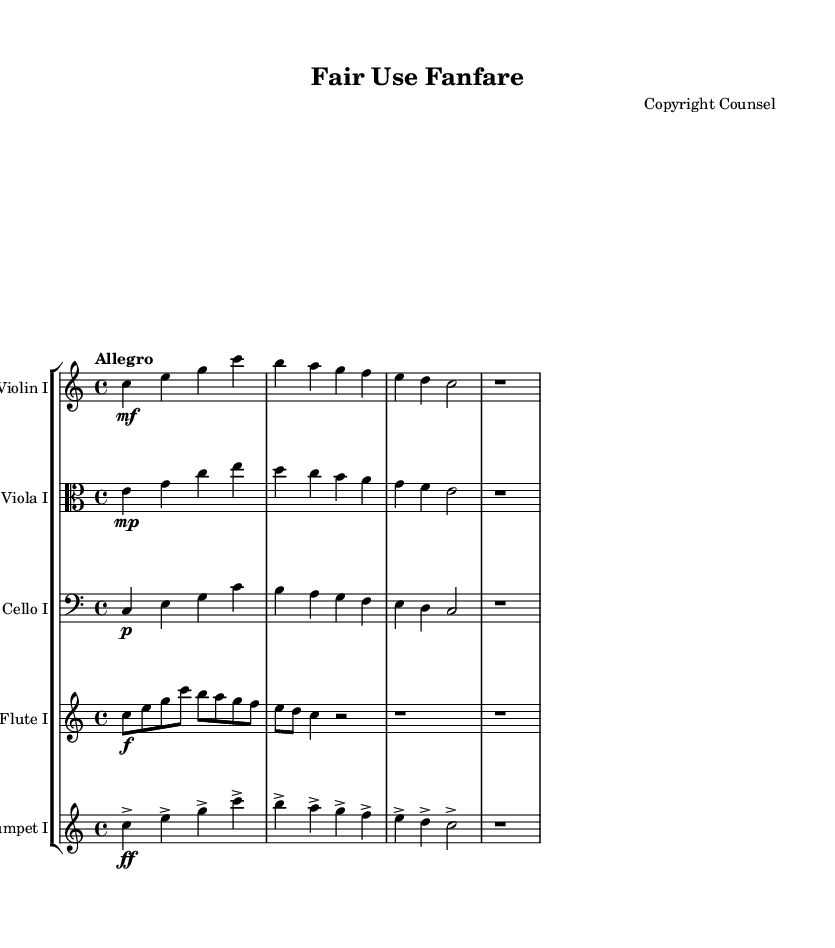what is the key signature of this music? The key signature is indicated at the beginning of the sheet music. In this case, it shows no sharps or flats, indicating C major.
Answer: C major what is the time signature of this music? The time signature is found at the beginning of the staff. It shows 4/4, which means there are four beats in a measure, and a quarter note gets one beat.
Answer: 4/4 what is the tempo marking for this piece? The tempo marking is provided above the staff in Italian terms. It reads "Allegro," which indicates a fast, lively tempo.
Answer: Allegro how many instruments are featured in the score? The score displays five individual staves, each representing a different instrument, which can be counted in the score.
Answer: 5 what dynamic marking is indicated for the trumpet line? The dynamic marking for the trumpet line appears at the beginning and indicates "ff," which means fortissimo, signaling a very loud volume.
Answer: fortissimo which instrument begins with a phrase starting on the note C? The phrases for each instrument can be observed, and the violin starts with the note C, making it the first note in its line.
Answer: Violin I which part has the most rapid note values? The flute part contains eighth notes in the beginning, making it the section with the fastest note values compared to the other instruments.
Answer: Flute I 